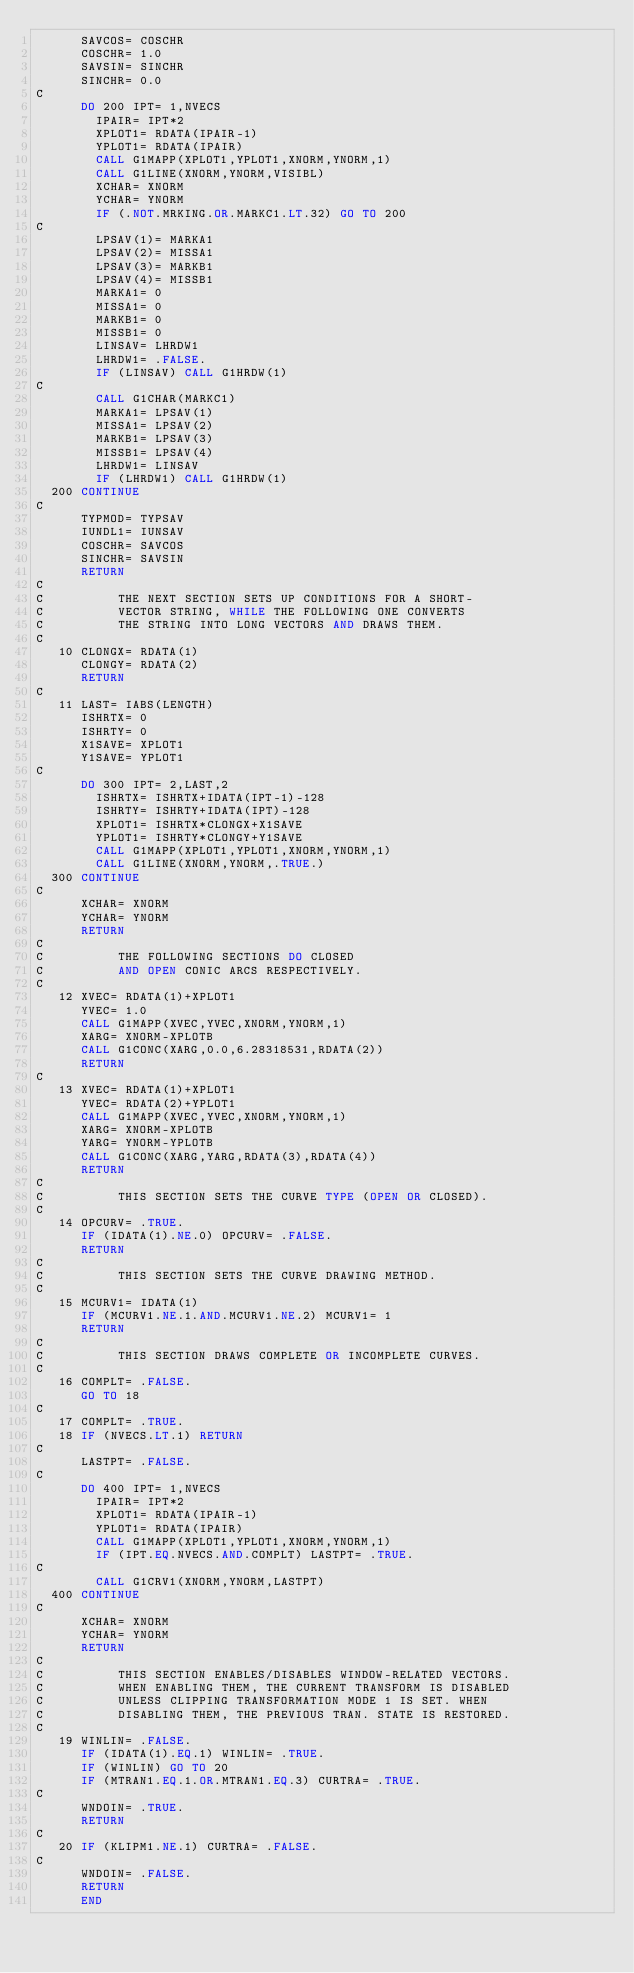<code> <loc_0><loc_0><loc_500><loc_500><_FORTRAN_>      SAVCOS= COSCHR
      COSCHR= 1.0
      SAVSIN= SINCHR
      SINCHR= 0.0
C
      DO 200 IPT= 1,NVECS
        IPAIR= IPT*2
        XPLOT1= RDATA(IPAIR-1)
        YPLOT1= RDATA(IPAIR)
        CALL G1MAPP(XPLOT1,YPLOT1,XNORM,YNORM,1)
        CALL G1LINE(XNORM,YNORM,VISIBL)
        XCHAR= XNORM
        YCHAR= YNORM
        IF (.NOT.MRKING.OR.MARKC1.LT.32) GO TO 200
C
        LPSAV(1)= MARKA1
        LPSAV(2)= MISSA1
        LPSAV(3)= MARKB1
        LPSAV(4)= MISSB1
        MARKA1= 0
        MISSA1= 0
        MARKB1= 0
        MISSB1= 0
        LINSAV= LHRDW1
        LHRDW1= .FALSE.
        IF (LINSAV) CALL G1HRDW(1)
C
        CALL G1CHAR(MARKC1)
        MARKA1= LPSAV(1)
        MISSA1= LPSAV(2)
        MARKB1= LPSAV(3)
        MISSB1= LPSAV(4)
        LHRDW1= LINSAV
        IF (LHRDW1) CALL G1HRDW(1)
  200 CONTINUE
C
      TYPMOD= TYPSAV
      IUNDL1= IUNSAV
      COSCHR= SAVCOS
      SINCHR= SAVSIN
      RETURN
C
C          THE NEXT SECTION SETS UP CONDITIONS FOR A SHORT-
C          VECTOR STRING, WHILE THE FOLLOWING ONE CONVERTS
C          THE STRING INTO LONG VECTORS AND DRAWS THEM.
C
   10 CLONGX= RDATA(1)
      CLONGY= RDATA(2)
      RETURN
C
   11 LAST= IABS(LENGTH)
      ISHRTX= 0
      ISHRTY= 0
      X1SAVE= XPLOT1
      Y1SAVE= YPLOT1
C
      DO 300 IPT= 2,LAST,2
        ISHRTX= ISHRTX+IDATA(IPT-1)-128
        ISHRTY= ISHRTY+IDATA(IPT)-128
        XPLOT1= ISHRTX*CLONGX+X1SAVE
        YPLOT1= ISHRTY*CLONGY+Y1SAVE
        CALL G1MAPP(XPLOT1,YPLOT1,XNORM,YNORM,1)
        CALL G1LINE(XNORM,YNORM,.TRUE.)
  300 CONTINUE
C
      XCHAR= XNORM
      YCHAR= YNORM
      RETURN
C
C          THE FOLLOWING SECTIONS DO CLOSED
C          AND OPEN CONIC ARCS RESPECTIVELY.
C
   12 XVEC= RDATA(1)+XPLOT1
      YVEC= 1.0
      CALL G1MAPP(XVEC,YVEC,XNORM,YNORM,1)
      XARG= XNORM-XPLOTB
      CALL G1CONC(XARG,0.0,6.28318531,RDATA(2))
      RETURN
C
   13 XVEC= RDATA(1)+XPLOT1
      YVEC= RDATA(2)+YPLOT1
      CALL G1MAPP(XVEC,YVEC,XNORM,YNORM,1)
      XARG= XNORM-XPLOTB
      YARG= YNORM-YPLOTB
      CALL G1CONC(XARG,YARG,RDATA(3),RDATA(4))
      RETURN
C
C          THIS SECTION SETS THE CURVE TYPE (OPEN OR CLOSED).
C
   14 OPCURV= .TRUE.
      IF (IDATA(1).NE.0) OPCURV= .FALSE.
      RETURN
C
C          THIS SECTION SETS THE CURVE DRAWING METHOD.
C
   15 MCURV1= IDATA(1)
      IF (MCURV1.NE.1.AND.MCURV1.NE.2) MCURV1= 1
      RETURN
C
C          THIS SECTION DRAWS COMPLETE OR INCOMPLETE CURVES.
C
   16 COMPLT= .FALSE.
      GO TO 18
C
   17 COMPLT= .TRUE.
   18 IF (NVECS.LT.1) RETURN
C
      LASTPT= .FALSE.
C
      DO 400 IPT= 1,NVECS
        IPAIR= IPT*2
        XPLOT1= RDATA(IPAIR-1)
        YPLOT1= RDATA(IPAIR)
        CALL G1MAPP(XPLOT1,YPLOT1,XNORM,YNORM,1)
        IF (IPT.EQ.NVECS.AND.COMPLT) LASTPT= .TRUE.
C
        CALL G1CRV1(XNORM,YNORM,LASTPT)
  400 CONTINUE
C
      XCHAR= XNORM
      YCHAR= YNORM
      RETURN
C
C          THIS SECTION ENABLES/DISABLES WINDOW-RELATED VECTORS.
C          WHEN ENABLING THEM, THE CURRENT TRANSFORM IS DISABLED
C          UNLESS CLIPPING TRANSFORMATION MODE 1 IS SET. WHEN
C          DISABLING THEM, THE PREVIOUS TRAN. STATE IS RESTORED.
C
   19 WINLIN= .FALSE.
      IF (IDATA(1).EQ.1) WINLIN= .TRUE.
      IF (WINLIN) GO TO 20
      IF (MTRAN1.EQ.1.OR.MTRAN1.EQ.3) CURTRA= .TRUE.
C
      WNDOIN= .TRUE.
      RETURN
C
   20 IF (KLIPM1.NE.1) CURTRA= .FALSE.
C
      WNDOIN= .FALSE.
      RETURN
      END
</code> 